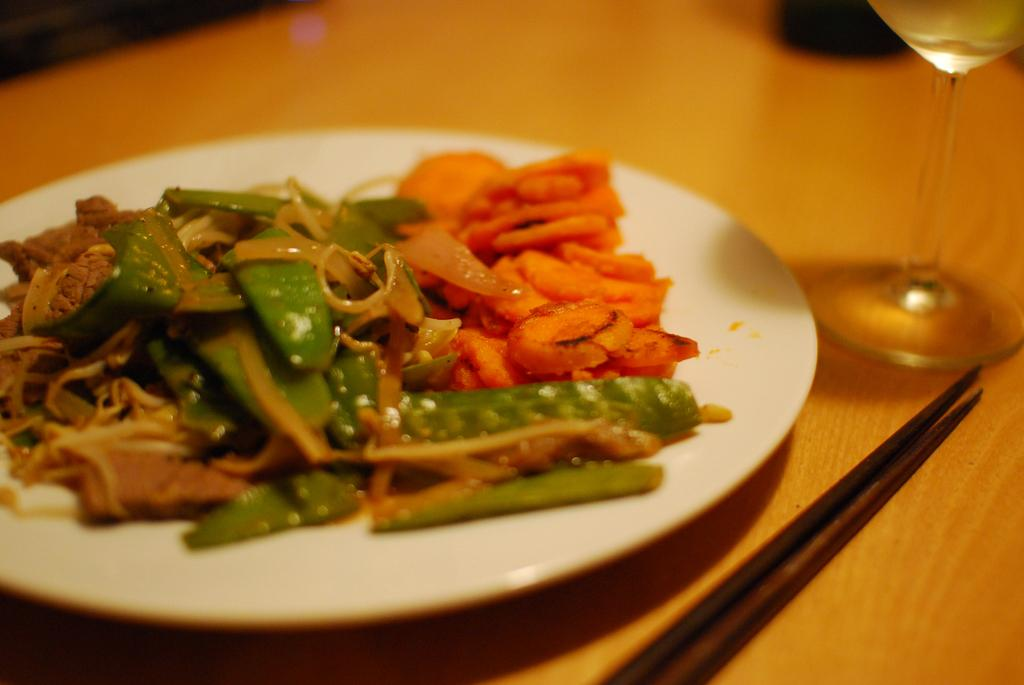What type of surface is visible in the image? There is a wooden surface in the image. What is placed on the wooden surface? There is a plate and a wine glass on the wooden surface. What is on the plate? There is a food item on the plate. How would you describe the background of the image? The background of the image is slightly blurred. How many crates are visible in the image? There are no crates present in the image. What type of currency is being exchanged in the image? There is no exchange of money depicted in the image. 